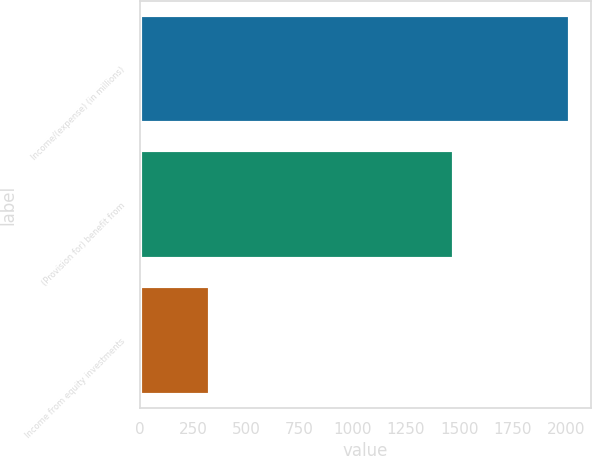Convert chart. <chart><loc_0><loc_0><loc_500><loc_500><bar_chart><fcel>Income/(expense) (in millions)<fcel>(Provision for) benefit from<fcel>Income from equity investments<nl><fcel>2018<fcel>1477<fcel>331<nl></chart> 